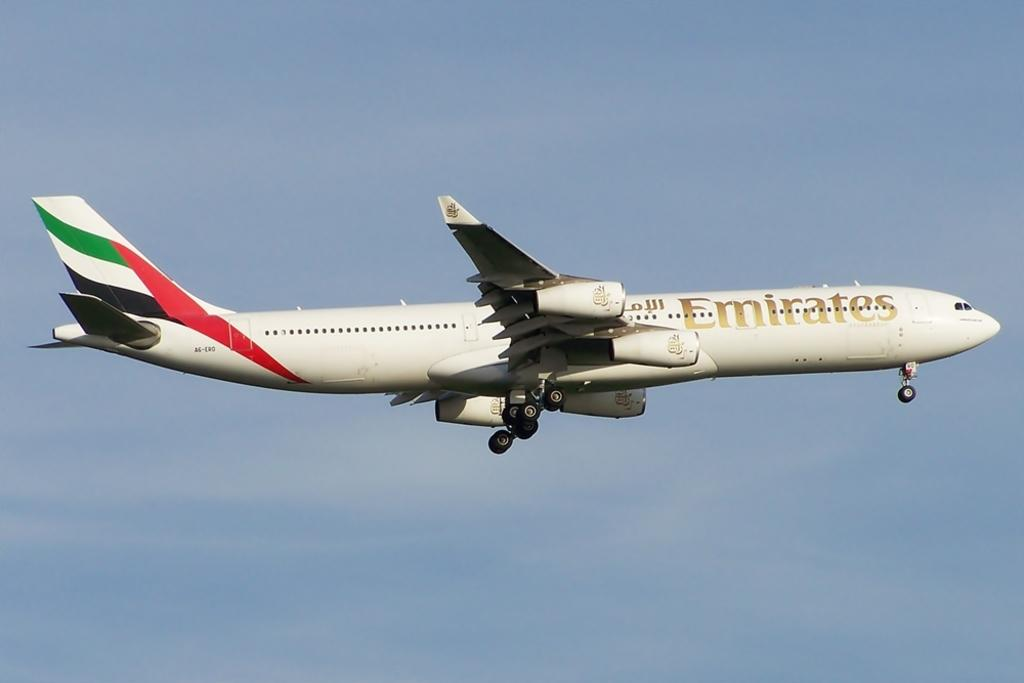<image>
Present a compact description of the photo's key features. an Emirates jet plane in the air shortly after take off 